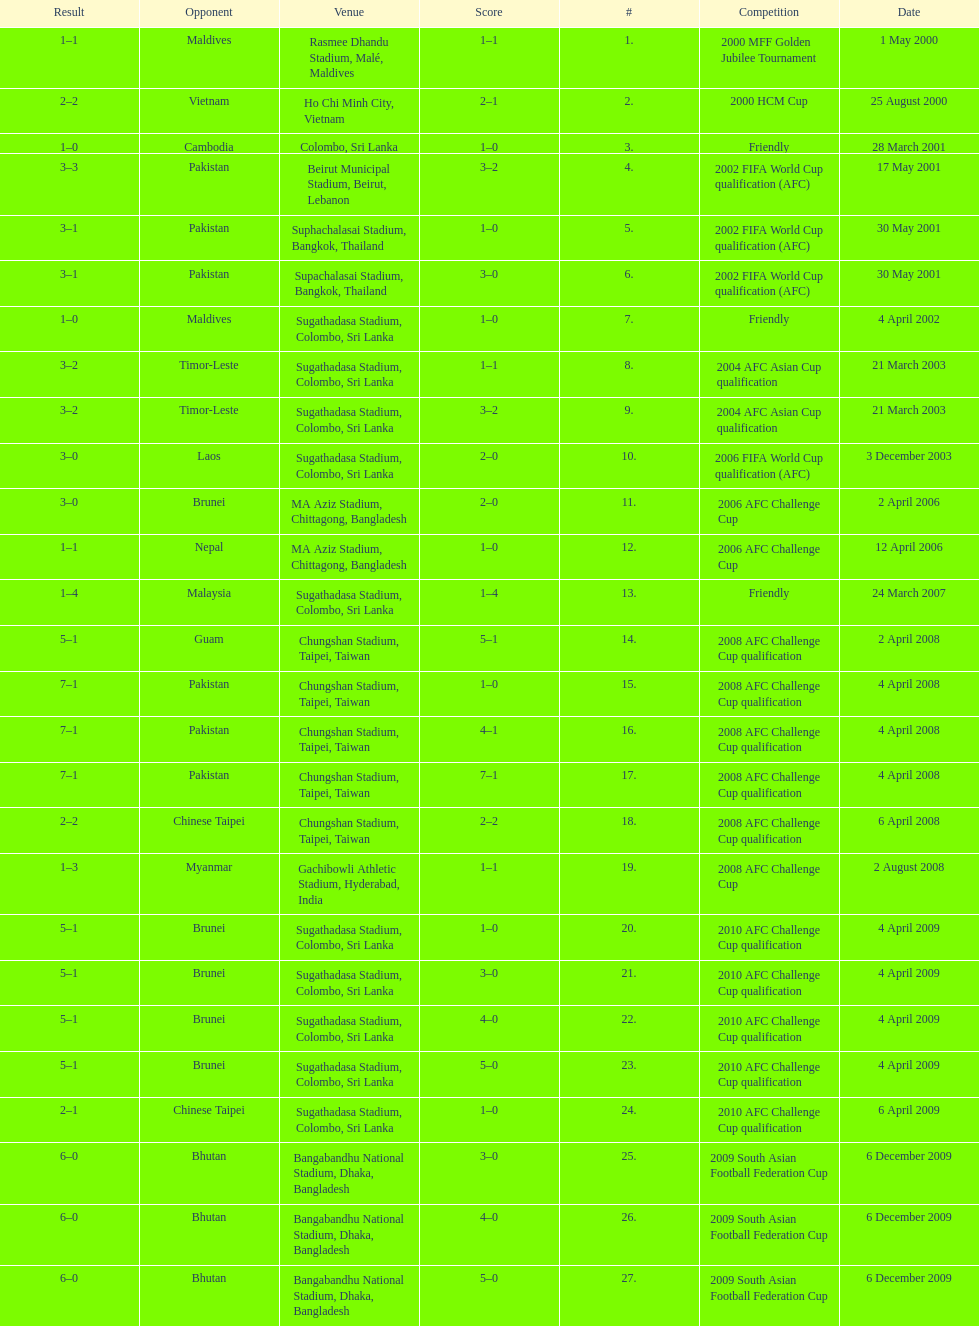In how many games did sri lanka score at least 2 goals? 16. 